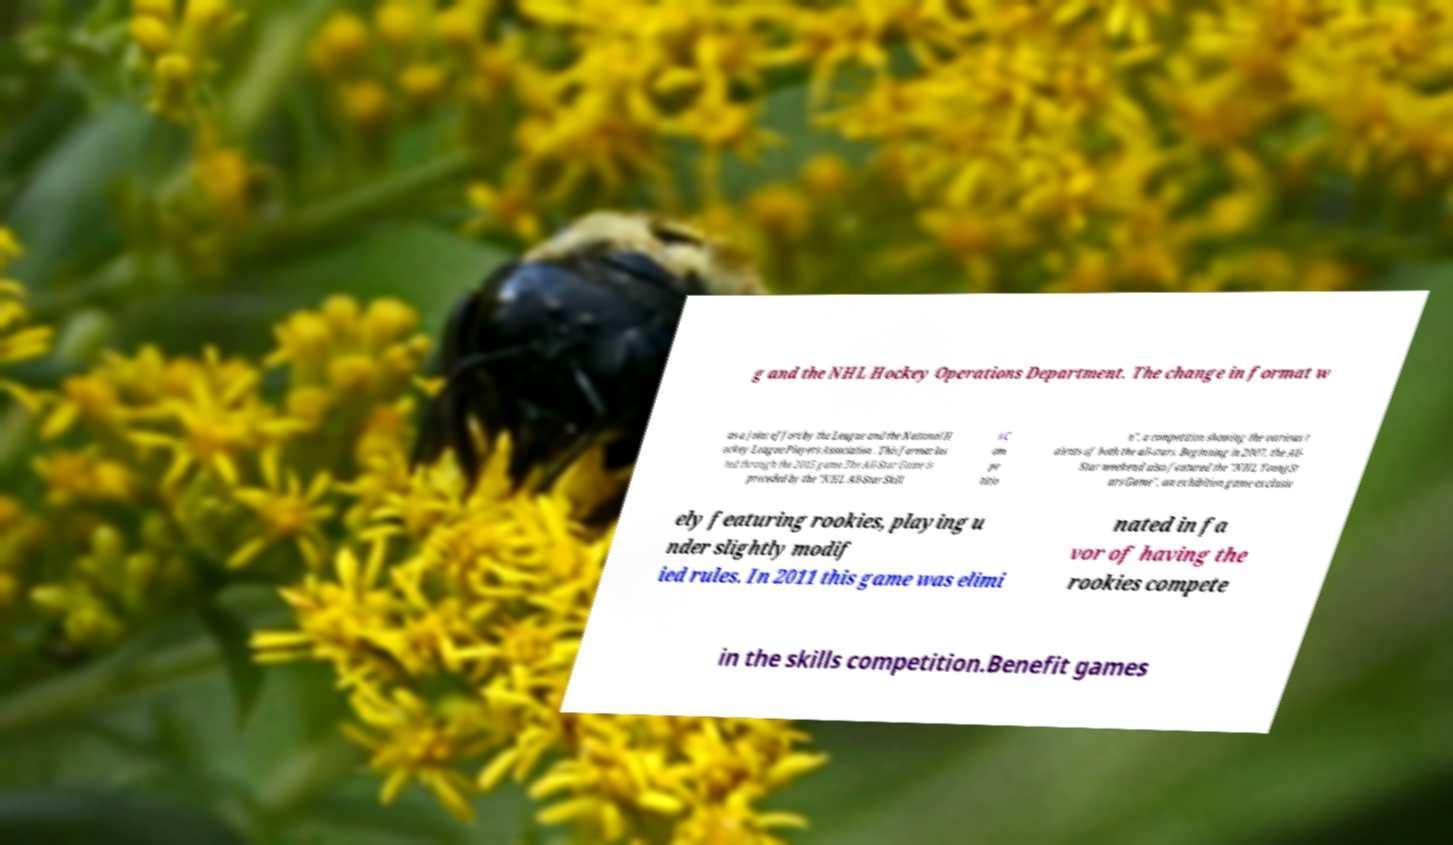Could you extract and type out the text from this image? g and the NHL Hockey Operations Department. The change in format w as a joint effort by the League and the National H ockey League Players Association . This format las ted through the 2015 game.The All-Star Game is preceded by the "NHL All-Star Skill s C om pe titio n", a competition showing the various t alents of both the all-stars. Beginning in 2007, the All- Star weekend also featured the "NHL YoungSt ars Game", an exhibition game exclusiv ely featuring rookies, playing u nder slightly modif ied rules. In 2011 this game was elimi nated in fa vor of having the rookies compete in the skills competition.Benefit games 